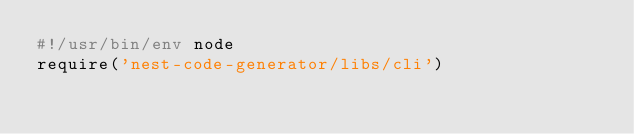Convert code to text. <code><loc_0><loc_0><loc_500><loc_500><_JavaScript_>#!/usr/bin/env node
require('nest-code-generator/libs/cli')

</code> 